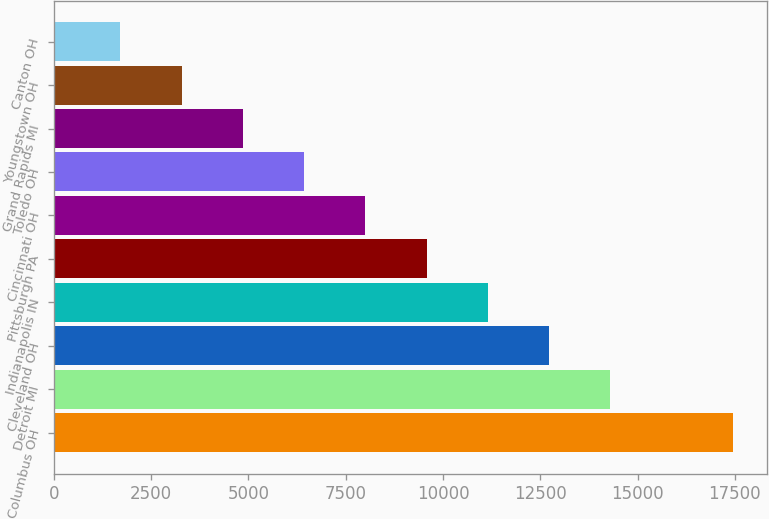Convert chart. <chart><loc_0><loc_0><loc_500><loc_500><bar_chart><fcel>Columbus OH<fcel>Detroit MI<fcel>Cleveland OH<fcel>Indianapolis IN<fcel>Pittsburgh PA<fcel>Cincinnati OH<fcel>Toledo OH<fcel>Grand Rapids MI<fcel>Youngstown OH<fcel>Canton OH<nl><fcel>17450<fcel>14301.6<fcel>12727.4<fcel>11153.2<fcel>9579<fcel>8004.8<fcel>6430.6<fcel>4856.4<fcel>3282.2<fcel>1708<nl></chart> 